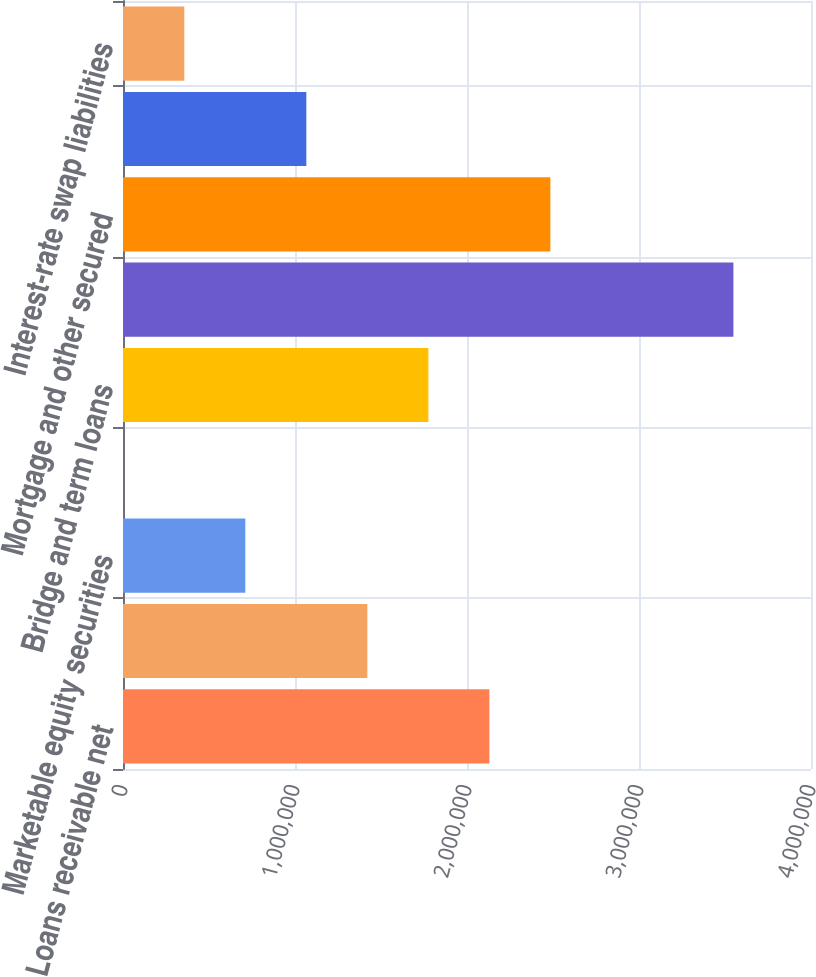<chart> <loc_0><loc_0><loc_500><loc_500><bar_chart><fcel>Loans receivable net<fcel>Marketable debt securities<fcel>Marketable equity securities<fcel>Warrants<fcel>Bridge and term loans<fcel>Senior unsecured notes<fcel>Mortgage and other secured<fcel>Other debt<fcel>Interest-rate swap liabilities<nl><fcel>2.13005e+06<fcel>1.42061e+06<fcel>711171<fcel>1732<fcel>1.77533e+06<fcel>3.54893e+06<fcel>2.48477e+06<fcel>1.06589e+06<fcel>356451<nl></chart> 